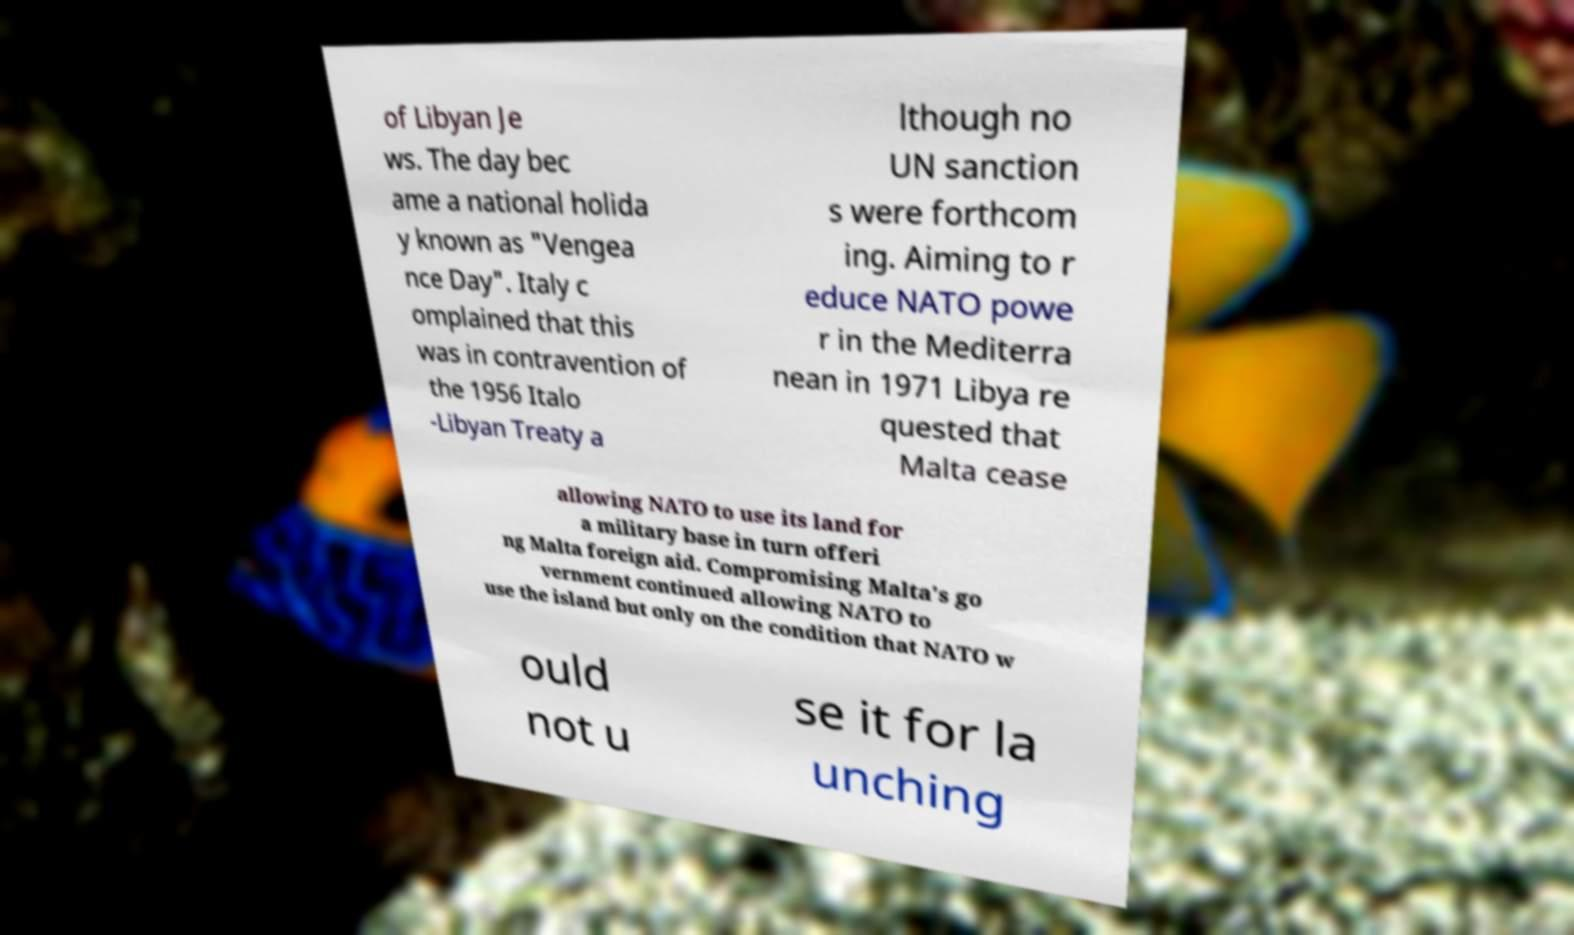There's text embedded in this image that I need extracted. Can you transcribe it verbatim? of Libyan Je ws. The day bec ame a national holida y known as "Vengea nce Day". Italy c omplained that this was in contravention of the 1956 Italo -Libyan Treaty a lthough no UN sanction s were forthcom ing. Aiming to r educe NATO powe r in the Mediterra nean in 1971 Libya re quested that Malta cease allowing NATO to use its land for a military base in turn offeri ng Malta foreign aid. Compromising Malta's go vernment continued allowing NATO to use the island but only on the condition that NATO w ould not u se it for la unching 